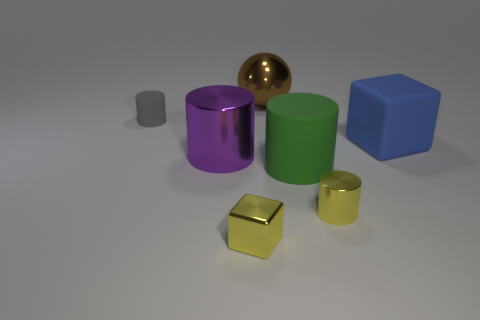Is the metallic cube the same color as the small metal cylinder?
Your answer should be very brief. Yes. What is the color of the other small metallic thing that is the same shape as the purple shiny thing?
Make the answer very short. Yellow. There is a big object to the left of the yellow metal cube; what shape is it?
Provide a succinct answer. Cylinder. There is a small cube; are there any shiny balls in front of it?
Provide a short and direct response. No. What is the color of the large object that is made of the same material as the blue cube?
Keep it short and to the point. Green. There is a tiny cylinder that is right of the big brown metal thing; is its color the same as the small metallic thing on the left side of the ball?
Make the answer very short. Yes. How many balls are small objects or big purple objects?
Your answer should be very brief. 0. Are there the same number of yellow cylinders on the left side of the small yellow shiny block and large green metallic balls?
Your answer should be compact. Yes. What is the material of the object that is right of the small cylinder that is in front of the big metallic thing that is to the left of the brown thing?
Give a very brief answer. Rubber. What material is the small thing that is the same color as the small shiny cylinder?
Give a very brief answer. Metal. 